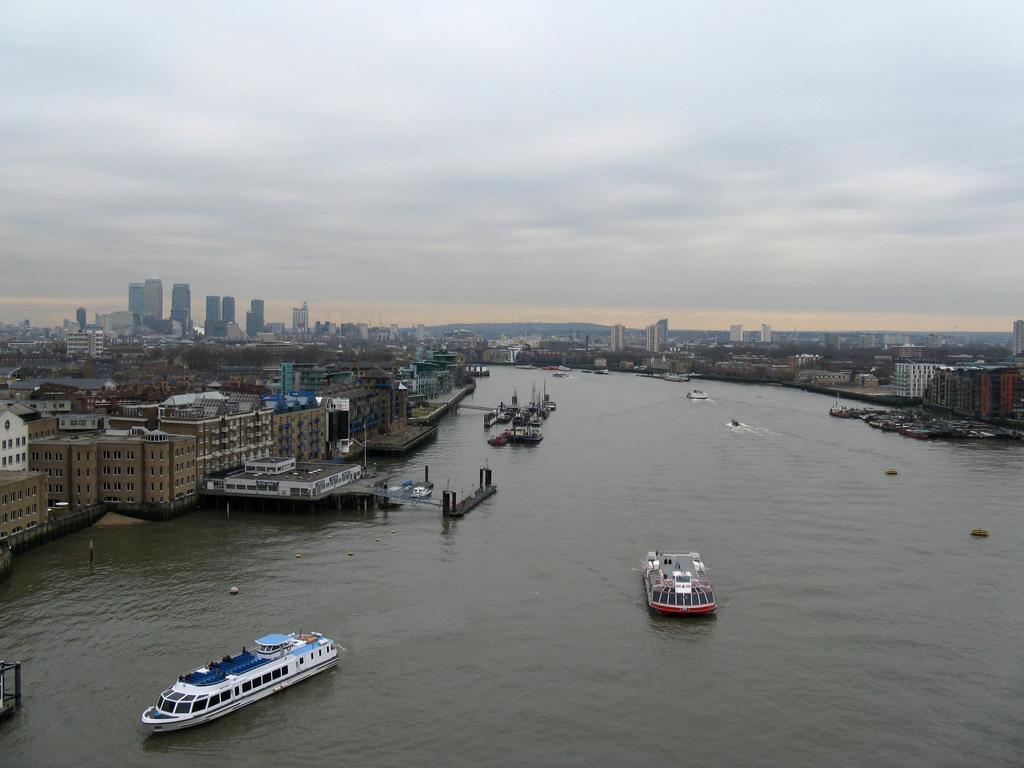In one or two sentences, can you explain what this image depicts? In this picture we can see boats on water, buildings, trees and in the background we can see the sky with clouds. 